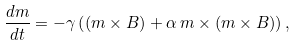Convert formula to latex. <formula><loc_0><loc_0><loc_500><loc_500>\frac { d m } { d t } = - \gamma \left ( ( m \times B ) + \alpha \, m \times ( m \times B ) \right ) ,</formula> 